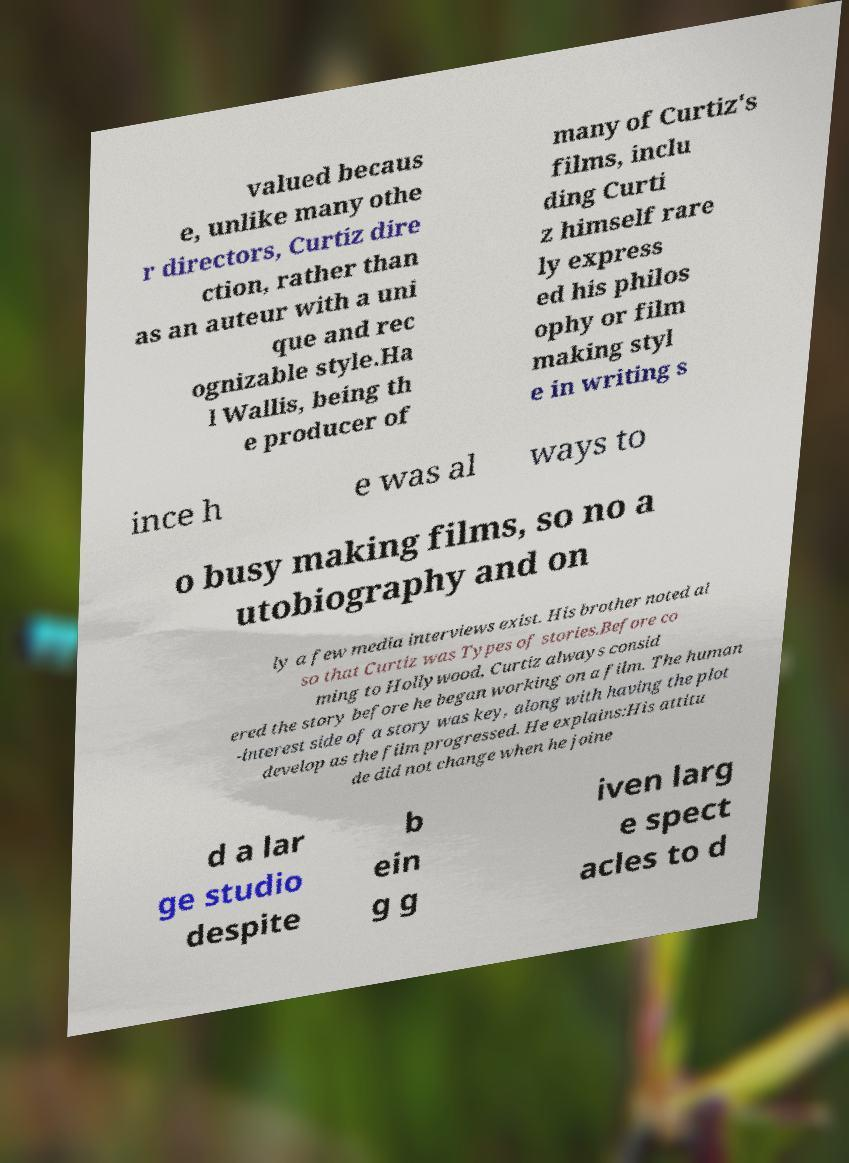Could you assist in decoding the text presented in this image and type it out clearly? valued becaus e, unlike many othe r directors, Curtiz dire ction, rather than as an auteur with a uni que and rec ognizable style.Ha l Wallis, being th e producer of many of Curtiz's films, inclu ding Curti z himself rare ly express ed his philos ophy or film making styl e in writing s ince h e was al ways to o busy making films, so no a utobiography and on ly a few media interviews exist. His brother noted al so that Curtiz was Types of stories.Before co ming to Hollywood, Curtiz always consid ered the story before he began working on a film. The human -interest side of a story was key, along with having the plot develop as the film progressed. He explains:His attitu de did not change when he joine d a lar ge studio despite b ein g g iven larg e spect acles to d 